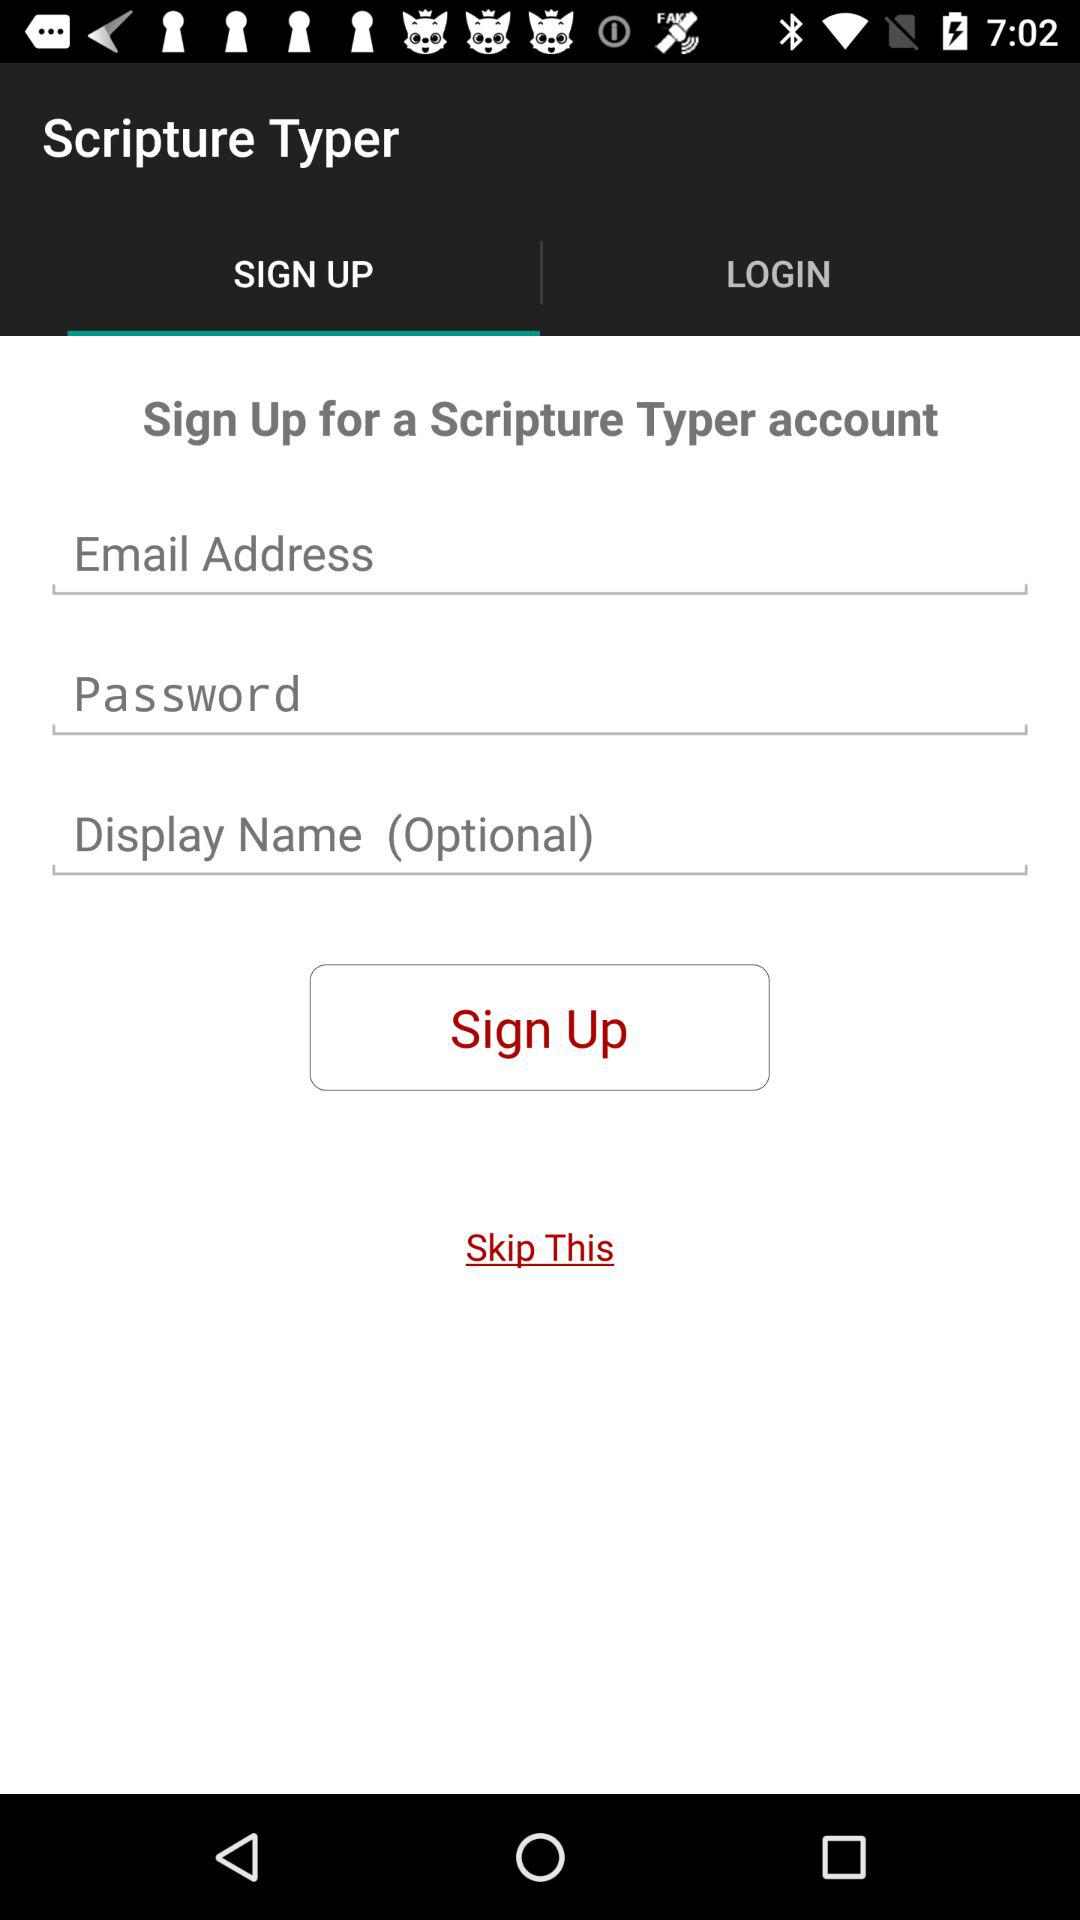What is the application name? The application name is "Scripture Typer". 